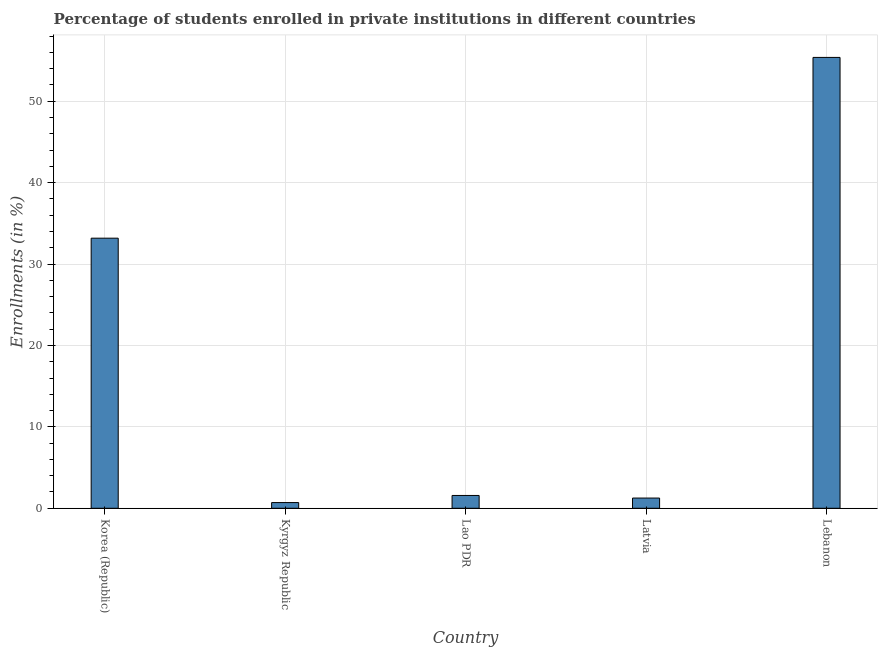Does the graph contain any zero values?
Offer a terse response. No. What is the title of the graph?
Ensure brevity in your answer.  Percentage of students enrolled in private institutions in different countries. What is the label or title of the X-axis?
Keep it short and to the point. Country. What is the label or title of the Y-axis?
Give a very brief answer. Enrollments (in %). What is the enrollments in private institutions in Korea (Republic)?
Ensure brevity in your answer.  33.18. Across all countries, what is the maximum enrollments in private institutions?
Offer a very short reply. 55.38. Across all countries, what is the minimum enrollments in private institutions?
Offer a very short reply. 0.7. In which country was the enrollments in private institutions maximum?
Offer a very short reply. Lebanon. In which country was the enrollments in private institutions minimum?
Your answer should be compact. Kyrgyz Republic. What is the sum of the enrollments in private institutions?
Ensure brevity in your answer.  92.09. What is the difference between the enrollments in private institutions in Korea (Republic) and Kyrgyz Republic?
Provide a succinct answer. 32.48. What is the average enrollments in private institutions per country?
Keep it short and to the point. 18.42. What is the median enrollments in private institutions?
Keep it short and to the point. 1.57. In how many countries, is the enrollments in private institutions greater than 22 %?
Keep it short and to the point. 2. What is the ratio of the enrollments in private institutions in Korea (Republic) to that in Latvia?
Keep it short and to the point. 26.43. What is the difference between the highest and the second highest enrollments in private institutions?
Your answer should be compact. 22.2. What is the difference between the highest and the lowest enrollments in private institutions?
Keep it short and to the point. 54.68. What is the Enrollments (in %) of Korea (Republic)?
Give a very brief answer. 33.18. What is the Enrollments (in %) in Kyrgyz Republic?
Give a very brief answer. 0.7. What is the Enrollments (in %) in Lao PDR?
Provide a succinct answer. 1.57. What is the Enrollments (in %) of Latvia?
Your answer should be compact. 1.26. What is the Enrollments (in %) in Lebanon?
Provide a succinct answer. 55.38. What is the difference between the Enrollments (in %) in Korea (Republic) and Kyrgyz Republic?
Offer a terse response. 32.48. What is the difference between the Enrollments (in %) in Korea (Republic) and Lao PDR?
Offer a very short reply. 31.6. What is the difference between the Enrollments (in %) in Korea (Republic) and Latvia?
Give a very brief answer. 31.92. What is the difference between the Enrollments (in %) in Korea (Republic) and Lebanon?
Provide a short and direct response. -22.21. What is the difference between the Enrollments (in %) in Kyrgyz Republic and Lao PDR?
Ensure brevity in your answer.  -0.87. What is the difference between the Enrollments (in %) in Kyrgyz Republic and Latvia?
Give a very brief answer. -0.56. What is the difference between the Enrollments (in %) in Kyrgyz Republic and Lebanon?
Keep it short and to the point. -54.68. What is the difference between the Enrollments (in %) in Lao PDR and Latvia?
Offer a terse response. 0.32. What is the difference between the Enrollments (in %) in Lao PDR and Lebanon?
Give a very brief answer. -53.81. What is the difference between the Enrollments (in %) in Latvia and Lebanon?
Your response must be concise. -54.13. What is the ratio of the Enrollments (in %) in Korea (Republic) to that in Kyrgyz Republic?
Offer a terse response. 47.4. What is the ratio of the Enrollments (in %) in Korea (Republic) to that in Lao PDR?
Provide a short and direct response. 21.08. What is the ratio of the Enrollments (in %) in Korea (Republic) to that in Latvia?
Give a very brief answer. 26.43. What is the ratio of the Enrollments (in %) in Korea (Republic) to that in Lebanon?
Keep it short and to the point. 0.6. What is the ratio of the Enrollments (in %) in Kyrgyz Republic to that in Lao PDR?
Offer a very short reply. 0.45. What is the ratio of the Enrollments (in %) in Kyrgyz Republic to that in Latvia?
Provide a succinct answer. 0.56. What is the ratio of the Enrollments (in %) in Kyrgyz Republic to that in Lebanon?
Your answer should be very brief. 0.01. What is the ratio of the Enrollments (in %) in Lao PDR to that in Latvia?
Provide a short and direct response. 1.25. What is the ratio of the Enrollments (in %) in Lao PDR to that in Lebanon?
Provide a short and direct response. 0.03. What is the ratio of the Enrollments (in %) in Latvia to that in Lebanon?
Make the answer very short. 0.02. 